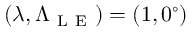<formula> <loc_0><loc_0><loc_500><loc_500>( \lambda , \Lambda _ { L E } ) = ( 1 , 0 ^ { \circ } )</formula> 